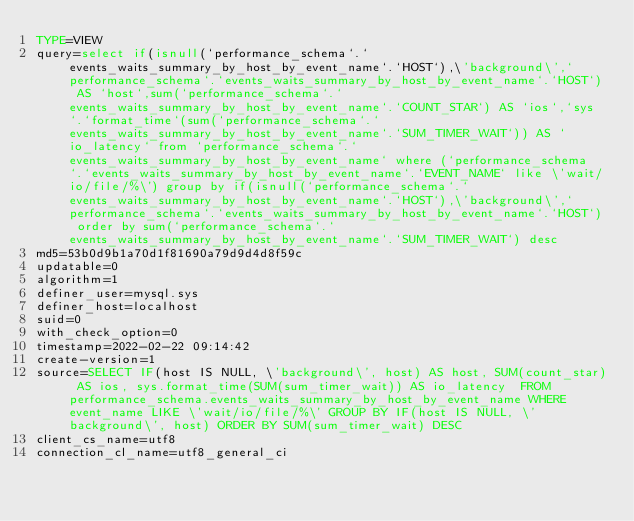Convert code to text. <code><loc_0><loc_0><loc_500><loc_500><_VisualBasic_>TYPE=VIEW
query=select if(isnull(`performance_schema`.`events_waits_summary_by_host_by_event_name`.`HOST`),\'background\',`performance_schema`.`events_waits_summary_by_host_by_event_name`.`HOST`) AS `host`,sum(`performance_schema`.`events_waits_summary_by_host_by_event_name`.`COUNT_STAR`) AS `ios`,`sys`.`format_time`(sum(`performance_schema`.`events_waits_summary_by_host_by_event_name`.`SUM_TIMER_WAIT`)) AS `io_latency` from `performance_schema`.`events_waits_summary_by_host_by_event_name` where (`performance_schema`.`events_waits_summary_by_host_by_event_name`.`EVENT_NAME` like \'wait/io/file/%\') group by if(isnull(`performance_schema`.`events_waits_summary_by_host_by_event_name`.`HOST`),\'background\',`performance_schema`.`events_waits_summary_by_host_by_event_name`.`HOST`) order by sum(`performance_schema`.`events_waits_summary_by_host_by_event_name`.`SUM_TIMER_WAIT`) desc
md5=53b0d9b1a70d1f81690a79d9d4d8f59c
updatable=0
algorithm=1
definer_user=mysql.sys
definer_host=localhost
suid=0
with_check_option=0
timestamp=2022-02-22 09:14:42
create-version=1
source=SELECT IF(host IS NULL, \'background\', host) AS host, SUM(count_star) AS ios, sys.format_time(SUM(sum_timer_wait)) AS io_latency  FROM performance_schema.events_waits_summary_by_host_by_event_name WHERE event_name LIKE \'wait/io/file/%\' GROUP BY IF(host IS NULL, \'background\', host) ORDER BY SUM(sum_timer_wait) DESC
client_cs_name=utf8
connection_cl_name=utf8_general_ci</code> 